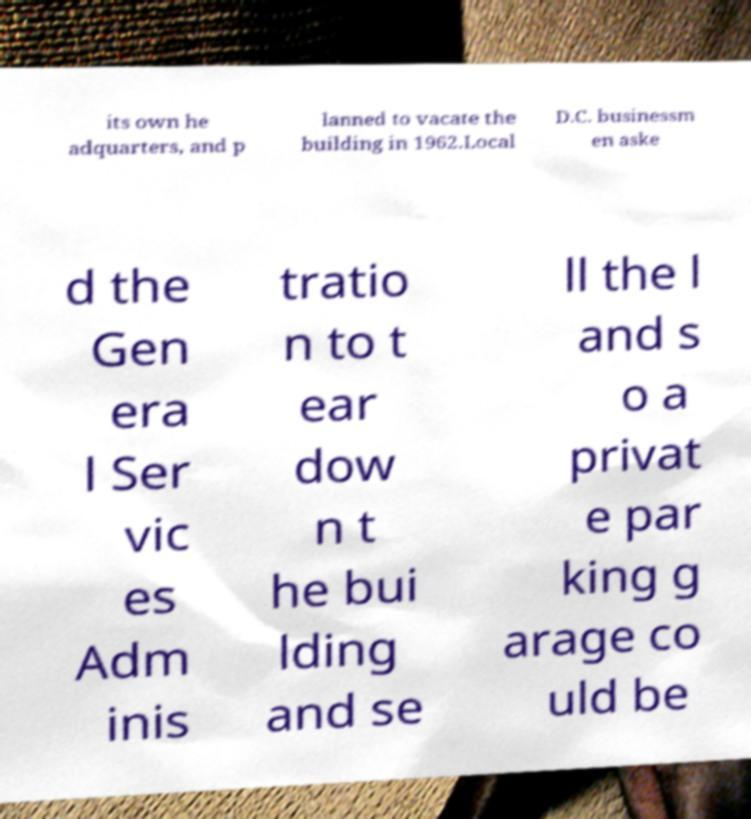Could you extract and type out the text from this image? its own he adquarters, and p lanned to vacate the building in 1962.Local D.C. businessm en aske d the Gen era l Ser vic es Adm inis tratio n to t ear dow n t he bui lding and se ll the l and s o a privat e par king g arage co uld be 